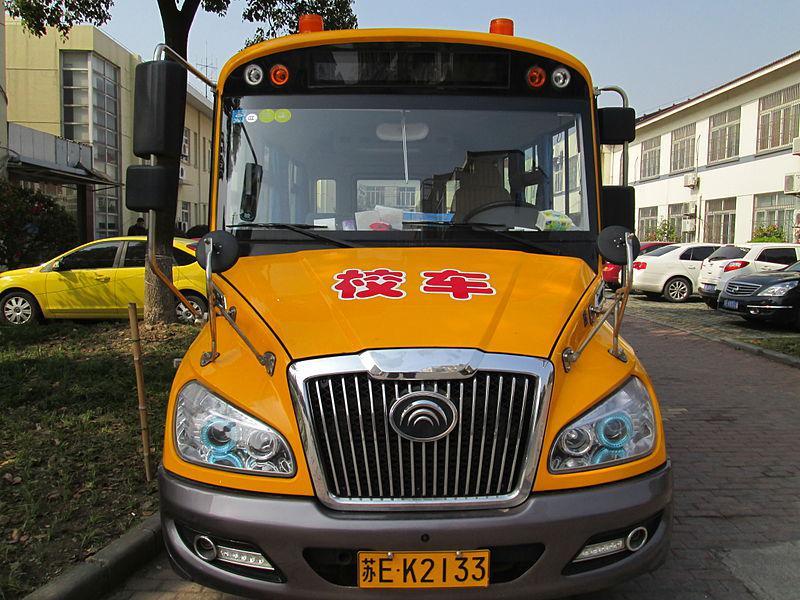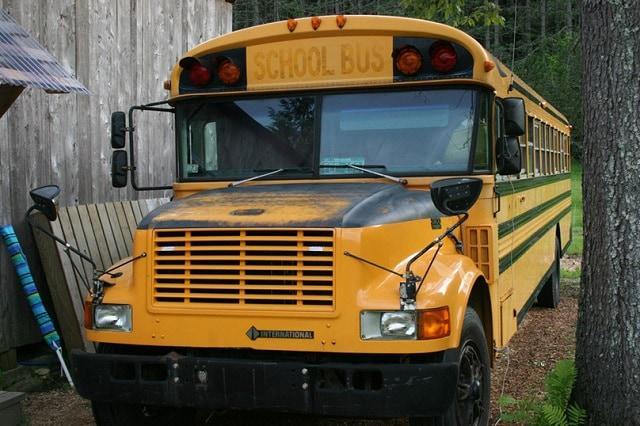The first image is the image on the left, the second image is the image on the right. Assess this claim about the two images: "In one of the images, the bus passenger door is open.". Correct or not? Answer yes or no. No. The first image is the image on the left, the second image is the image on the right. For the images shown, is this caption "The right image shows a leftward-angled non-flat bus, and the left image shows the front of a parked non-flat bus that has only one hood and grille and has a license plate on its front bumper." true? Answer yes or no. Yes. 